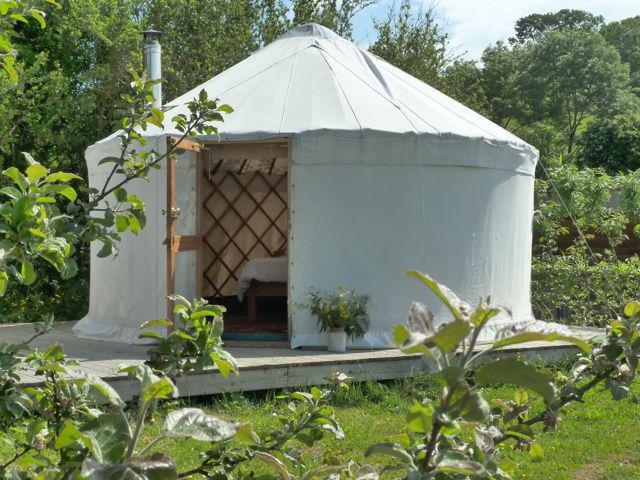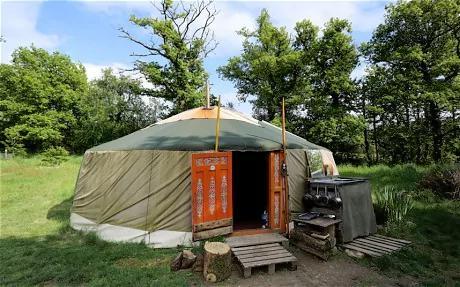The first image is the image on the left, the second image is the image on the right. Assess this claim about the two images: "there is exactly one person in the image on the right.". Correct or not? Answer yes or no. No. 